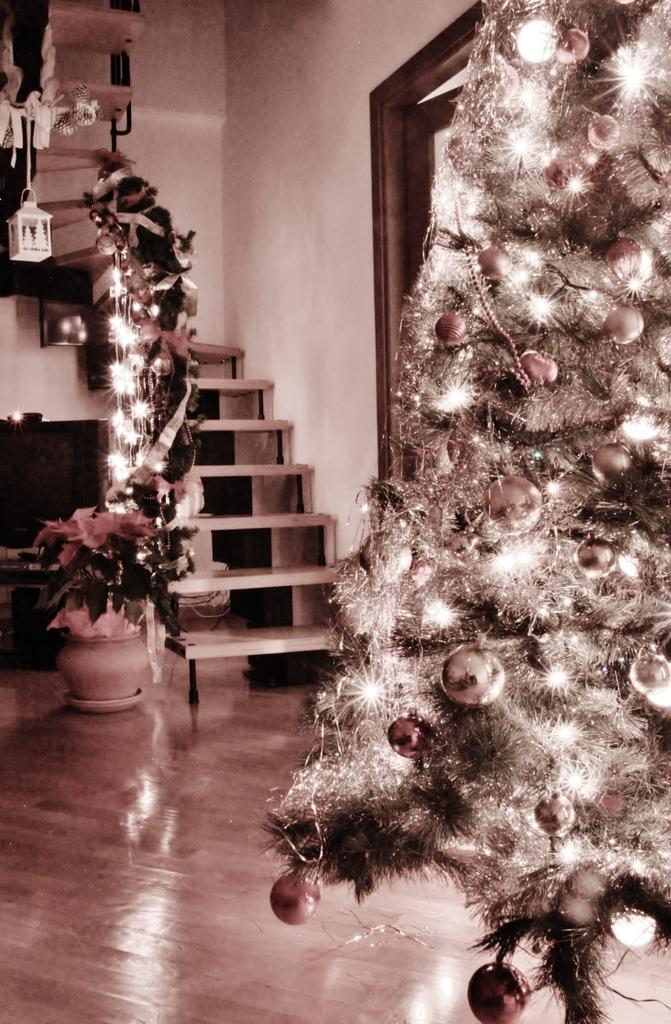What is the main subject of the picture? The main subject of the picture is a Christmas tree. What else can be seen on the left side of the image? There is a flower pot on the left side of the image. What architectural feature is present in the middle of the image? There are stairs in the middle of the image. How many attempts were made to catch the pest in the image? There is no mention of a pest in the image, so it is not possible to determine the number of attempts made to catch it. 